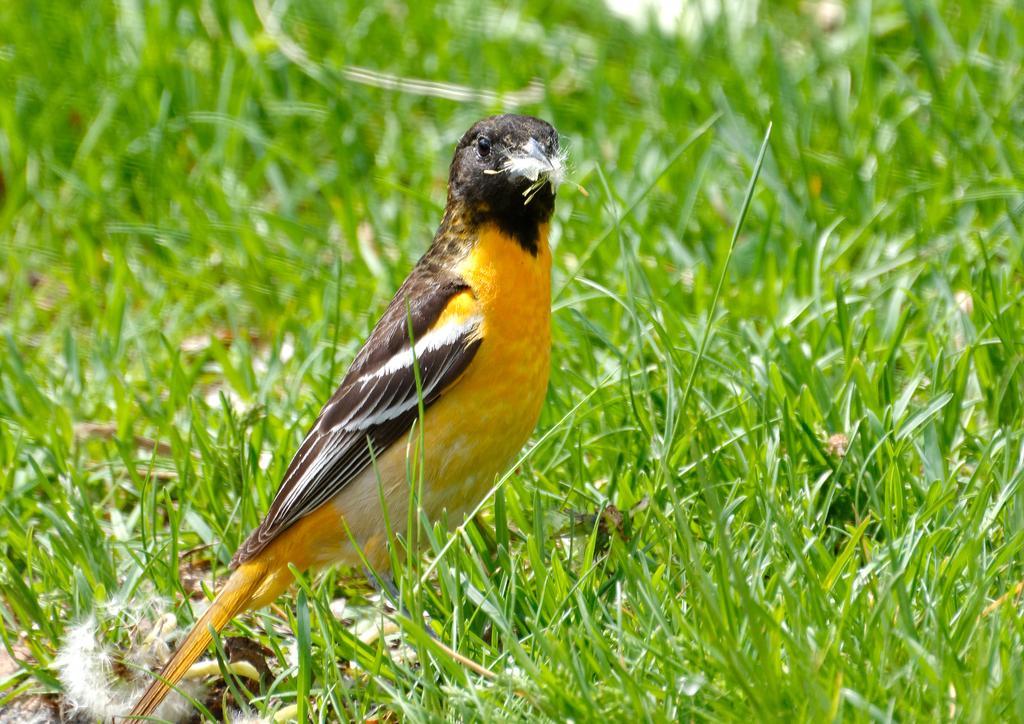How would you summarize this image in a sentence or two? In this image on the ground there is a bird. On the ground there are grasses. 